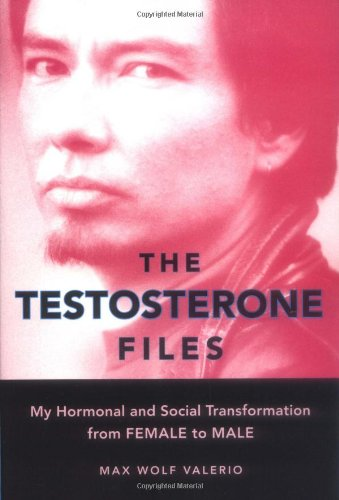Who wrote this book? The book 'The Testosterone Files' was authored by Max Wolf Valerio, a writer known for exploring his experiences of gender transition. 